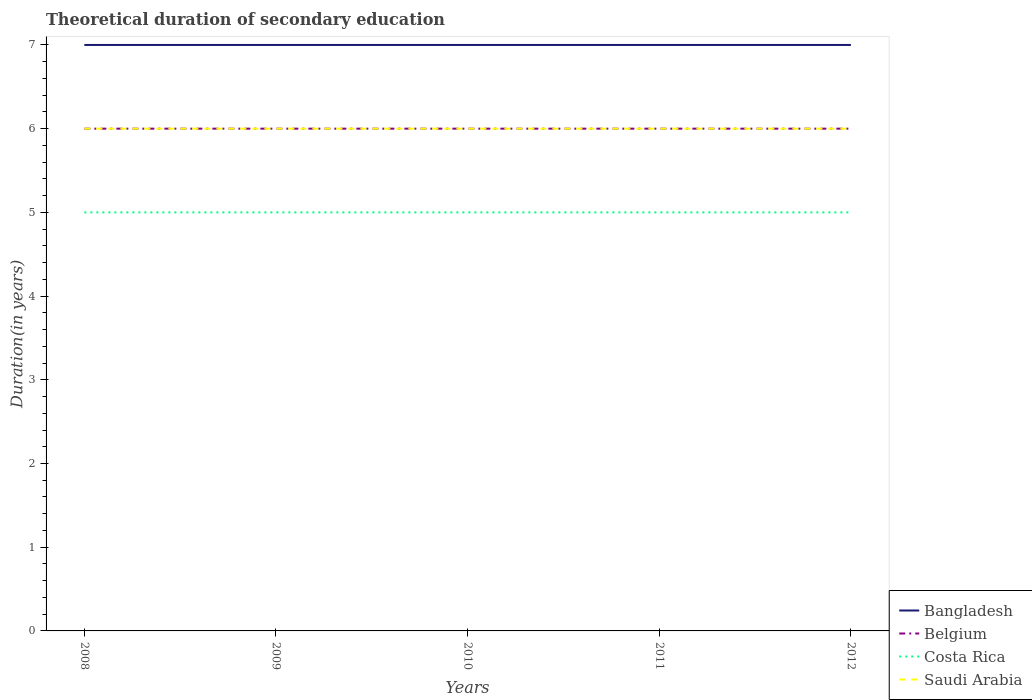How many different coloured lines are there?
Provide a succinct answer. 4. Across all years, what is the maximum total theoretical duration of secondary education in Costa Rica?
Provide a short and direct response. 5. In which year was the total theoretical duration of secondary education in Bangladesh maximum?
Your answer should be compact. 2008. What is the difference between the highest and the lowest total theoretical duration of secondary education in Costa Rica?
Make the answer very short. 0. Is the total theoretical duration of secondary education in Belgium strictly greater than the total theoretical duration of secondary education in Bangladesh over the years?
Offer a terse response. Yes. How many lines are there?
Keep it short and to the point. 4. How many years are there in the graph?
Give a very brief answer. 5. Are the values on the major ticks of Y-axis written in scientific E-notation?
Your answer should be compact. No. Where does the legend appear in the graph?
Your answer should be very brief. Bottom right. How are the legend labels stacked?
Offer a terse response. Vertical. What is the title of the graph?
Keep it short and to the point. Theoretical duration of secondary education. Does "Gambia, The" appear as one of the legend labels in the graph?
Provide a short and direct response. No. What is the label or title of the Y-axis?
Offer a very short reply. Duration(in years). What is the Duration(in years) of Bangladesh in 2008?
Offer a terse response. 7. What is the Duration(in years) of Costa Rica in 2008?
Give a very brief answer. 5. What is the Duration(in years) of Saudi Arabia in 2008?
Provide a short and direct response. 6. What is the Duration(in years) of Bangladesh in 2009?
Your response must be concise. 7. What is the Duration(in years) in Costa Rica in 2009?
Your answer should be compact. 5. What is the Duration(in years) of Saudi Arabia in 2009?
Provide a succinct answer. 6. What is the Duration(in years) in Bangladesh in 2010?
Provide a succinct answer. 7. What is the Duration(in years) in Costa Rica in 2010?
Your response must be concise. 5. What is the Duration(in years) of Bangladesh in 2011?
Your answer should be compact. 7. What is the Duration(in years) of Belgium in 2011?
Your response must be concise. 6. What is the Duration(in years) of Bangladesh in 2012?
Ensure brevity in your answer.  7. What is the Duration(in years) of Belgium in 2012?
Provide a short and direct response. 6. What is the Duration(in years) of Costa Rica in 2012?
Provide a succinct answer. 5. What is the Duration(in years) in Saudi Arabia in 2012?
Offer a terse response. 6. Across all years, what is the maximum Duration(in years) in Costa Rica?
Offer a terse response. 5. Across all years, what is the minimum Duration(in years) in Bangladesh?
Your answer should be compact. 7. What is the total Duration(in years) of Costa Rica in the graph?
Offer a very short reply. 25. What is the total Duration(in years) of Saudi Arabia in the graph?
Offer a terse response. 30. What is the difference between the Duration(in years) of Bangladesh in 2008 and that in 2009?
Offer a very short reply. 0. What is the difference between the Duration(in years) in Costa Rica in 2008 and that in 2009?
Give a very brief answer. 0. What is the difference between the Duration(in years) in Saudi Arabia in 2008 and that in 2009?
Your answer should be compact. 0. What is the difference between the Duration(in years) in Belgium in 2008 and that in 2010?
Ensure brevity in your answer.  0. What is the difference between the Duration(in years) of Costa Rica in 2008 and that in 2010?
Your response must be concise. 0. What is the difference between the Duration(in years) in Costa Rica in 2008 and that in 2011?
Make the answer very short. 0. What is the difference between the Duration(in years) of Bangladesh in 2008 and that in 2012?
Give a very brief answer. 0. What is the difference between the Duration(in years) in Costa Rica in 2008 and that in 2012?
Offer a very short reply. 0. What is the difference between the Duration(in years) of Bangladesh in 2009 and that in 2010?
Offer a very short reply. 0. What is the difference between the Duration(in years) in Belgium in 2009 and that in 2010?
Keep it short and to the point. 0. What is the difference between the Duration(in years) in Bangladesh in 2009 and that in 2011?
Your answer should be compact. 0. What is the difference between the Duration(in years) of Bangladesh in 2009 and that in 2012?
Ensure brevity in your answer.  0. What is the difference between the Duration(in years) in Belgium in 2009 and that in 2012?
Your answer should be very brief. 0. What is the difference between the Duration(in years) of Costa Rica in 2009 and that in 2012?
Offer a very short reply. 0. What is the difference between the Duration(in years) of Saudi Arabia in 2009 and that in 2012?
Make the answer very short. 0. What is the difference between the Duration(in years) of Belgium in 2010 and that in 2011?
Make the answer very short. 0. What is the difference between the Duration(in years) of Bangladesh in 2010 and that in 2012?
Your answer should be very brief. 0. What is the difference between the Duration(in years) in Belgium in 2010 and that in 2012?
Give a very brief answer. 0. What is the difference between the Duration(in years) of Saudi Arabia in 2010 and that in 2012?
Offer a very short reply. 0. What is the difference between the Duration(in years) in Bangladesh in 2011 and that in 2012?
Your answer should be compact. 0. What is the difference between the Duration(in years) of Bangladesh in 2008 and the Duration(in years) of Costa Rica in 2009?
Your answer should be compact. 2. What is the difference between the Duration(in years) of Belgium in 2008 and the Duration(in years) of Costa Rica in 2009?
Offer a very short reply. 1. What is the difference between the Duration(in years) of Bangladesh in 2008 and the Duration(in years) of Saudi Arabia in 2010?
Ensure brevity in your answer.  1. What is the difference between the Duration(in years) in Belgium in 2008 and the Duration(in years) in Saudi Arabia in 2010?
Your answer should be very brief. 0. What is the difference between the Duration(in years) in Costa Rica in 2008 and the Duration(in years) in Saudi Arabia in 2010?
Make the answer very short. -1. What is the difference between the Duration(in years) of Bangladesh in 2008 and the Duration(in years) of Saudi Arabia in 2011?
Ensure brevity in your answer.  1. What is the difference between the Duration(in years) in Belgium in 2008 and the Duration(in years) in Costa Rica in 2011?
Offer a very short reply. 1. What is the difference between the Duration(in years) in Belgium in 2008 and the Duration(in years) in Saudi Arabia in 2012?
Your answer should be compact. 0. What is the difference between the Duration(in years) in Costa Rica in 2008 and the Duration(in years) in Saudi Arabia in 2012?
Give a very brief answer. -1. What is the difference between the Duration(in years) in Bangladesh in 2009 and the Duration(in years) in Saudi Arabia in 2010?
Offer a terse response. 1. What is the difference between the Duration(in years) in Belgium in 2009 and the Duration(in years) in Costa Rica in 2010?
Ensure brevity in your answer.  1. What is the difference between the Duration(in years) in Belgium in 2009 and the Duration(in years) in Saudi Arabia in 2010?
Provide a short and direct response. 0. What is the difference between the Duration(in years) in Bangladesh in 2009 and the Duration(in years) in Belgium in 2011?
Give a very brief answer. 1. What is the difference between the Duration(in years) of Bangladesh in 2009 and the Duration(in years) of Costa Rica in 2011?
Ensure brevity in your answer.  2. What is the difference between the Duration(in years) in Bangladesh in 2009 and the Duration(in years) in Saudi Arabia in 2011?
Keep it short and to the point. 1. What is the difference between the Duration(in years) in Costa Rica in 2009 and the Duration(in years) in Saudi Arabia in 2011?
Provide a short and direct response. -1. What is the difference between the Duration(in years) in Belgium in 2009 and the Duration(in years) in Costa Rica in 2012?
Provide a succinct answer. 1. What is the difference between the Duration(in years) of Belgium in 2009 and the Duration(in years) of Saudi Arabia in 2012?
Your response must be concise. 0. What is the difference between the Duration(in years) of Bangladesh in 2010 and the Duration(in years) of Belgium in 2011?
Your answer should be compact. 1. What is the difference between the Duration(in years) of Bangladesh in 2010 and the Duration(in years) of Costa Rica in 2011?
Your response must be concise. 2. What is the difference between the Duration(in years) of Costa Rica in 2010 and the Duration(in years) of Saudi Arabia in 2011?
Ensure brevity in your answer.  -1. What is the difference between the Duration(in years) in Bangladesh in 2010 and the Duration(in years) in Belgium in 2012?
Offer a very short reply. 1. What is the difference between the Duration(in years) of Bangladesh in 2010 and the Duration(in years) of Saudi Arabia in 2012?
Your answer should be very brief. 1. What is the difference between the Duration(in years) in Belgium in 2010 and the Duration(in years) in Saudi Arabia in 2012?
Make the answer very short. 0. What is the difference between the Duration(in years) in Bangladesh in 2011 and the Duration(in years) in Costa Rica in 2012?
Provide a short and direct response. 2. What is the difference between the Duration(in years) of Bangladesh in 2011 and the Duration(in years) of Saudi Arabia in 2012?
Keep it short and to the point. 1. What is the difference between the Duration(in years) in Belgium in 2011 and the Duration(in years) in Saudi Arabia in 2012?
Your answer should be very brief. 0. What is the average Duration(in years) in Costa Rica per year?
Your answer should be very brief. 5. In the year 2008, what is the difference between the Duration(in years) in Bangladesh and Duration(in years) in Belgium?
Make the answer very short. 1. In the year 2008, what is the difference between the Duration(in years) in Bangladesh and Duration(in years) in Saudi Arabia?
Your answer should be compact. 1. In the year 2008, what is the difference between the Duration(in years) of Belgium and Duration(in years) of Saudi Arabia?
Keep it short and to the point. 0. In the year 2008, what is the difference between the Duration(in years) in Costa Rica and Duration(in years) in Saudi Arabia?
Ensure brevity in your answer.  -1. In the year 2009, what is the difference between the Duration(in years) of Bangladesh and Duration(in years) of Belgium?
Provide a short and direct response. 1. In the year 2009, what is the difference between the Duration(in years) of Bangladesh and Duration(in years) of Costa Rica?
Give a very brief answer. 2. In the year 2009, what is the difference between the Duration(in years) in Bangladesh and Duration(in years) in Saudi Arabia?
Make the answer very short. 1. In the year 2009, what is the difference between the Duration(in years) of Belgium and Duration(in years) of Saudi Arabia?
Your answer should be compact. 0. In the year 2009, what is the difference between the Duration(in years) of Costa Rica and Duration(in years) of Saudi Arabia?
Make the answer very short. -1. In the year 2010, what is the difference between the Duration(in years) in Bangladesh and Duration(in years) in Saudi Arabia?
Your response must be concise. 1. In the year 2011, what is the difference between the Duration(in years) of Bangladesh and Duration(in years) of Belgium?
Provide a succinct answer. 1. In the year 2011, what is the difference between the Duration(in years) of Bangladesh and Duration(in years) of Costa Rica?
Your response must be concise. 2. In the year 2011, what is the difference between the Duration(in years) in Belgium and Duration(in years) in Costa Rica?
Your answer should be compact. 1. In the year 2012, what is the difference between the Duration(in years) in Bangladesh and Duration(in years) in Belgium?
Your answer should be very brief. 1. In the year 2012, what is the difference between the Duration(in years) of Bangladesh and Duration(in years) of Costa Rica?
Ensure brevity in your answer.  2. In the year 2012, what is the difference between the Duration(in years) of Belgium and Duration(in years) of Costa Rica?
Keep it short and to the point. 1. In the year 2012, what is the difference between the Duration(in years) in Belgium and Duration(in years) in Saudi Arabia?
Provide a succinct answer. 0. In the year 2012, what is the difference between the Duration(in years) of Costa Rica and Duration(in years) of Saudi Arabia?
Make the answer very short. -1. What is the ratio of the Duration(in years) in Belgium in 2008 to that in 2009?
Offer a very short reply. 1. What is the ratio of the Duration(in years) of Costa Rica in 2008 to that in 2009?
Offer a terse response. 1. What is the ratio of the Duration(in years) of Costa Rica in 2008 to that in 2010?
Offer a very short reply. 1. What is the ratio of the Duration(in years) of Saudi Arabia in 2008 to that in 2010?
Provide a short and direct response. 1. What is the ratio of the Duration(in years) of Costa Rica in 2008 to that in 2011?
Make the answer very short. 1. What is the ratio of the Duration(in years) of Saudi Arabia in 2008 to that in 2011?
Make the answer very short. 1. What is the ratio of the Duration(in years) of Belgium in 2008 to that in 2012?
Give a very brief answer. 1. What is the ratio of the Duration(in years) of Costa Rica in 2008 to that in 2012?
Your response must be concise. 1. What is the ratio of the Duration(in years) in Saudi Arabia in 2008 to that in 2012?
Your response must be concise. 1. What is the ratio of the Duration(in years) in Bangladesh in 2009 to that in 2010?
Make the answer very short. 1. What is the ratio of the Duration(in years) in Saudi Arabia in 2009 to that in 2011?
Provide a succinct answer. 1. What is the ratio of the Duration(in years) of Costa Rica in 2009 to that in 2012?
Provide a short and direct response. 1. What is the ratio of the Duration(in years) of Saudi Arabia in 2009 to that in 2012?
Offer a terse response. 1. What is the ratio of the Duration(in years) of Bangladesh in 2010 to that in 2011?
Ensure brevity in your answer.  1. What is the ratio of the Duration(in years) of Belgium in 2010 to that in 2011?
Your response must be concise. 1. What is the ratio of the Duration(in years) in Costa Rica in 2010 to that in 2011?
Provide a short and direct response. 1. What is the difference between the highest and the second highest Duration(in years) of Bangladesh?
Your answer should be very brief. 0. What is the difference between the highest and the second highest Duration(in years) of Belgium?
Your response must be concise. 0. What is the difference between the highest and the second highest Duration(in years) of Saudi Arabia?
Keep it short and to the point. 0. What is the difference between the highest and the lowest Duration(in years) in Bangladesh?
Your answer should be very brief. 0. What is the difference between the highest and the lowest Duration(in years) of Belgium?
Give a very brief answer. 0. What is the difference between the highest and the lowest Duration(in years) of Costa Rica?
Ensure brevity in your answer.  0. What is the difference between the highest and the lowest Duration(in years) in Saudi Arabia?
Keep it short and to the point. 0. 